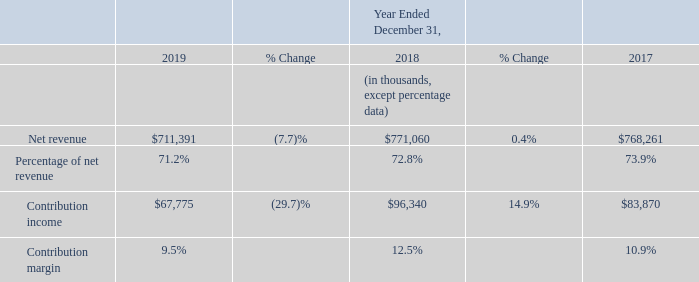2019 vs 2018
Net revenue in Connected Home segment decreased for the year ended December 31, 2019 compared to the prior year. Net revenue from service provider customers fell $27.8 million compared with the prior year. In addition, the North American home WiFi market contracted in fiscal 2019 affecting net revenue from non-service provider customers. The lower revenue was primarily due to declined net revenue of our home wireless, mobile and broadband modem and gateway products. Within home wireless, we experienced declines in net revenue from AC router products, WiFi mesh systems and extenders, partially offset by net revenue generated from the introduction of WiFi 6 routers. On a geographic basis, we experience net revenue declines across all three regions.
Contribution income decreased for the year ended December 31, 2019 compared to the prior year, primarily due to lower net revenue and lower gross margin attainment. Contribution margin decreased for the year ended December 31, 2019 compare to the prior year primarily due to higher product acquisition costs resulting from the burden of Section 301 tariffs and inefficiencies associated with commencing manufacturing in new locations, increased channel promotion activities and foreign exchange headwinds due to the strengthening of the U.S. dollar.
2018 vs 2017
2018 vs 2017 Connected Home segment net revenue increased for the year ended December 31, 2018 compared to the prior year. The increase in Connected Home net revenue was primarily due to home wireless and broadband modem and modem gateway products, partially offset by decreased net revenue from mobile products. The growth in home wireless was experienced across both service provider and non-service provider channels, while the increase in broadband and gateway related solely to non-service provider customers. In total, net revenue from service provider customers fell $33.5 million compared to the prior year period. Geographically, net revenue increased in Americas and EMEA, but decreased in APAC.
Contribution income increased for the year ended December 31, 2018 compared to the prior year, primarily due to higher net revenue and gross margin attainment, mainly due to favorable product mix and lower warranty expense, partially offset by higher operating expenses as a proportion of net revenue.
How much did the net revenue from service provider customers decrease from 2018 to 2019? $27.8 million. What accounts for the increase in net revenue in 2018? Due to home wireless and broadband modem and modem gateway products, partially offset by decreased net revenue from mobile products. Which region did the net revenue decrease in 2018? Apac. What was the percentage change in net revenue from 2017 to 2019?
Answer scale should be: percent. (711,391 - 768,261)/768,261 
Answer: -7.4. In which year is the percentage of net revenue the lowest? 71.2% < 72.8% < 73.9%
Answer: 2019. What was the change in contribution income from 2018 to 2019?
Answer scale should be: thousand. $67,775 - $96,340 
Answer: -28565. 